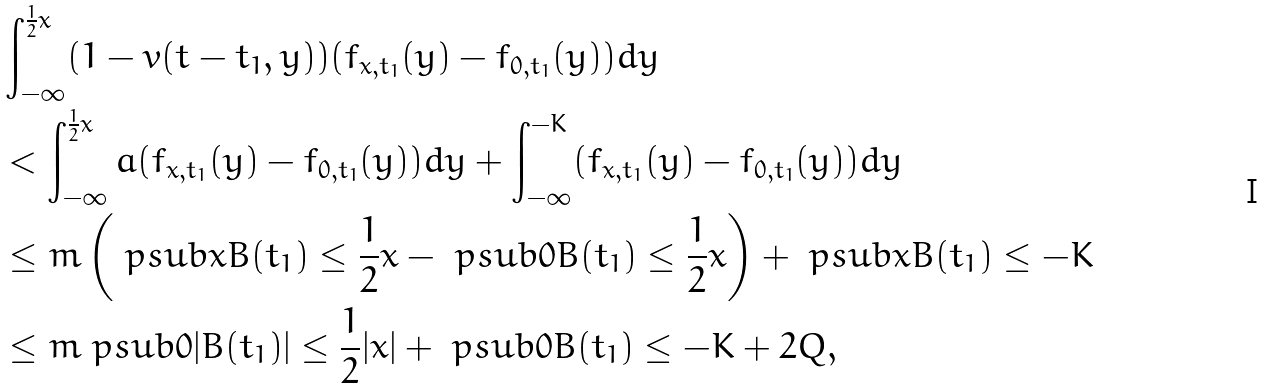Convert formula to latex. <formula><loc_0><loc_0><loc_500><loc_500>& \int ^ { \frac { 1 } { 2 } x } _ { - \infty } ( 1 - v ( t - t _ { 1 } , y ) ) ( f _ { x , t _ { 1 } } ( y ) - f _ { 0 , t _ { 1 } } ( y ) ) d y \\ & < \int ^ { \frac { 1 } { 2 } x } _ { - \infty } a ( f _ { x , t _ { 1 } } ( y ) - f _ { 0 , t _ { 1 } } ( y ) ) d y + \int ^ { - K } _ { - \infty } ( f _ { x , t _ { 1 } } ( y ) - f _ { 0 , t _ { 1 } } ( y ) ) d y \\ & \leq m \left ( \ p s u b { x } { B ( t _ { 1 } ) \leq \frac { 1 } { 2 } x } - \ p s u b { 0 } { B ( t _ { 1 } ) \leq \frac { 1 } { 2 } x } \right ) + \ p s u b { x } { B ( t _ { 1 } ) \leq - K } \\ & \leq m \ p s u b { 0 } { | B ( t _ { 1 } ) | \leq \frac { 1 } { 2 } | x | } + \ p s u b { 0 } { B ( t _ { 1 } ) \leq - K + 2 Q } ,</formula> 